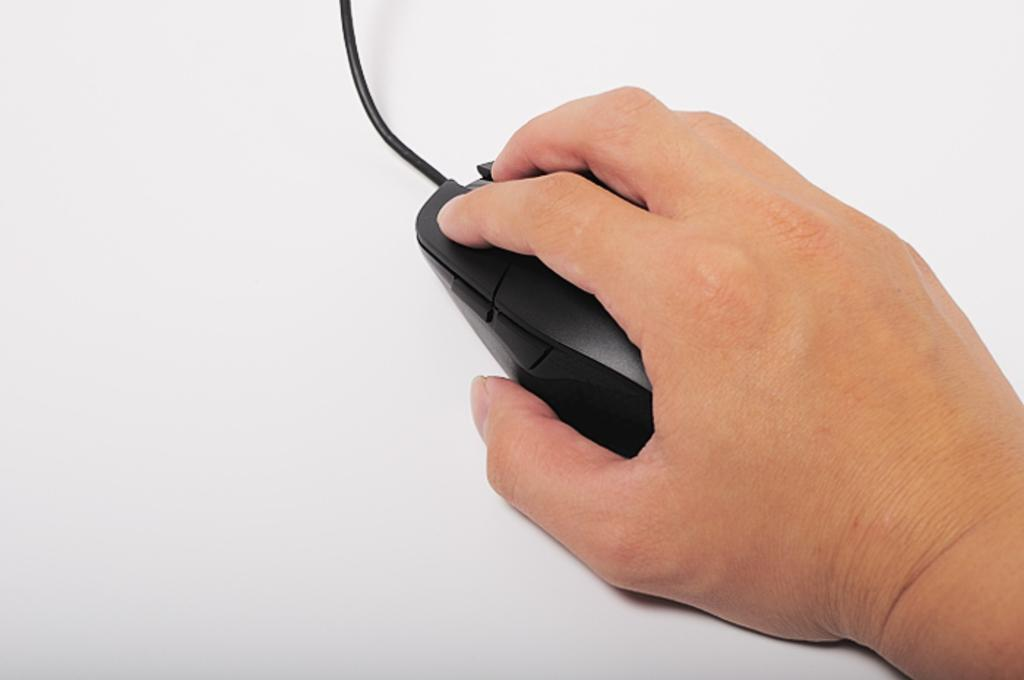What is the person's hand holding in the image? The person's hand is holding a mouse in the image. On which side of the image is the hand located? The hand is on the right side of the image. What can be seen connected to the mouse? There is a cable visible in the image. What object in the background might the hand and mouse be resting on? There is a white object that seems to be a table in the background of the image. What type of bell can be heard ringing in the image? There is no bell present in the image, and therefore no sound can be heard. 